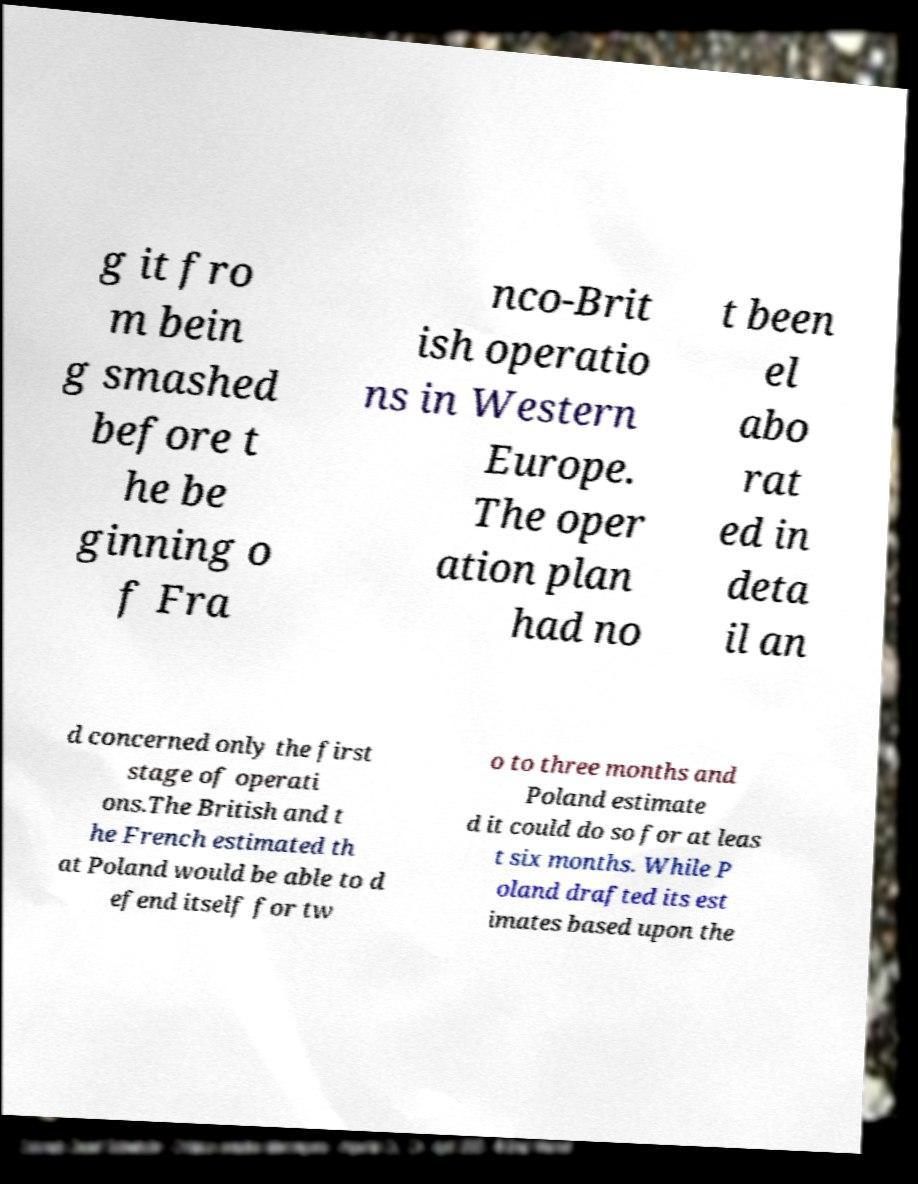For documentation purposes, I need the text within this image transcribed. Could you provide that? g it fro m bein g smashed before t he be ginning o f Fra nco-Brit ish operatio ns in Western Europe. The oper ation plan had no t been el abo rat ed in deta il an d concerned only the first stage of operati ons.The British and t he French estimated th at Poland would be able to d efend itself for tw o to three months and Poland estimate d it could do so for at leas t six months. While P oland drafted its est imates based upon the 